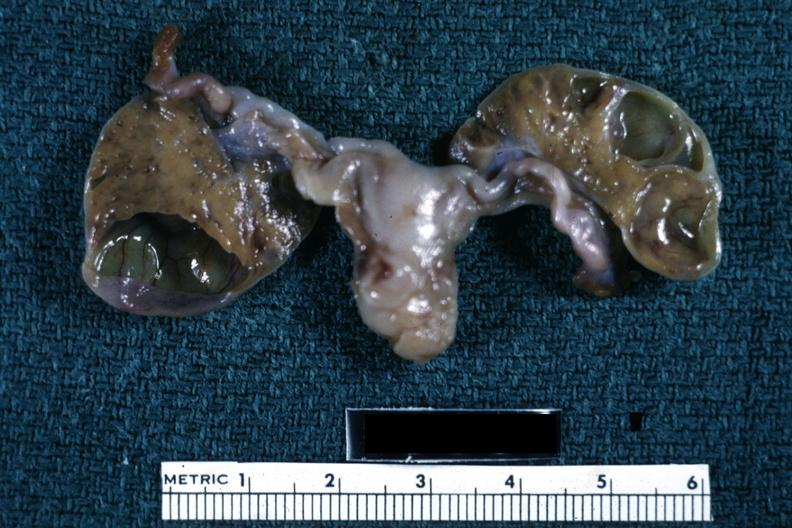what does this image show?
Answer the question using a single word or phrase. Fixed tissue close-up well shown tan-orange luteum tissue cysts in sliced ovaries three day old 